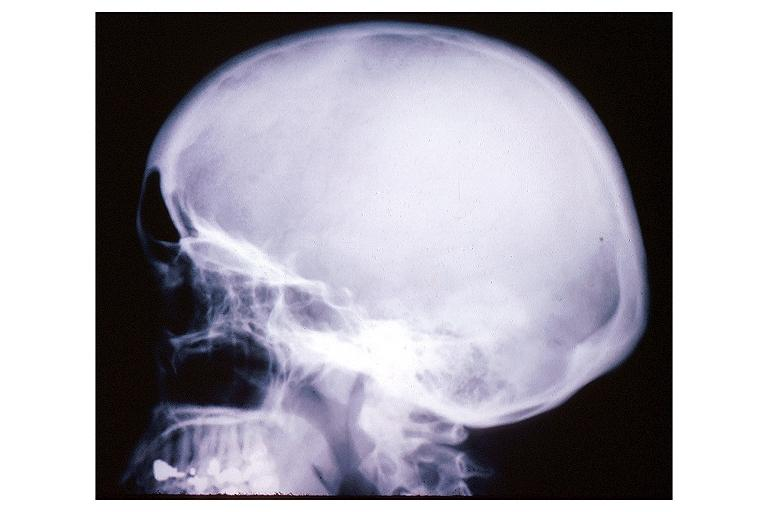what is present?
Answer the question using a single word or phrase. Oral 